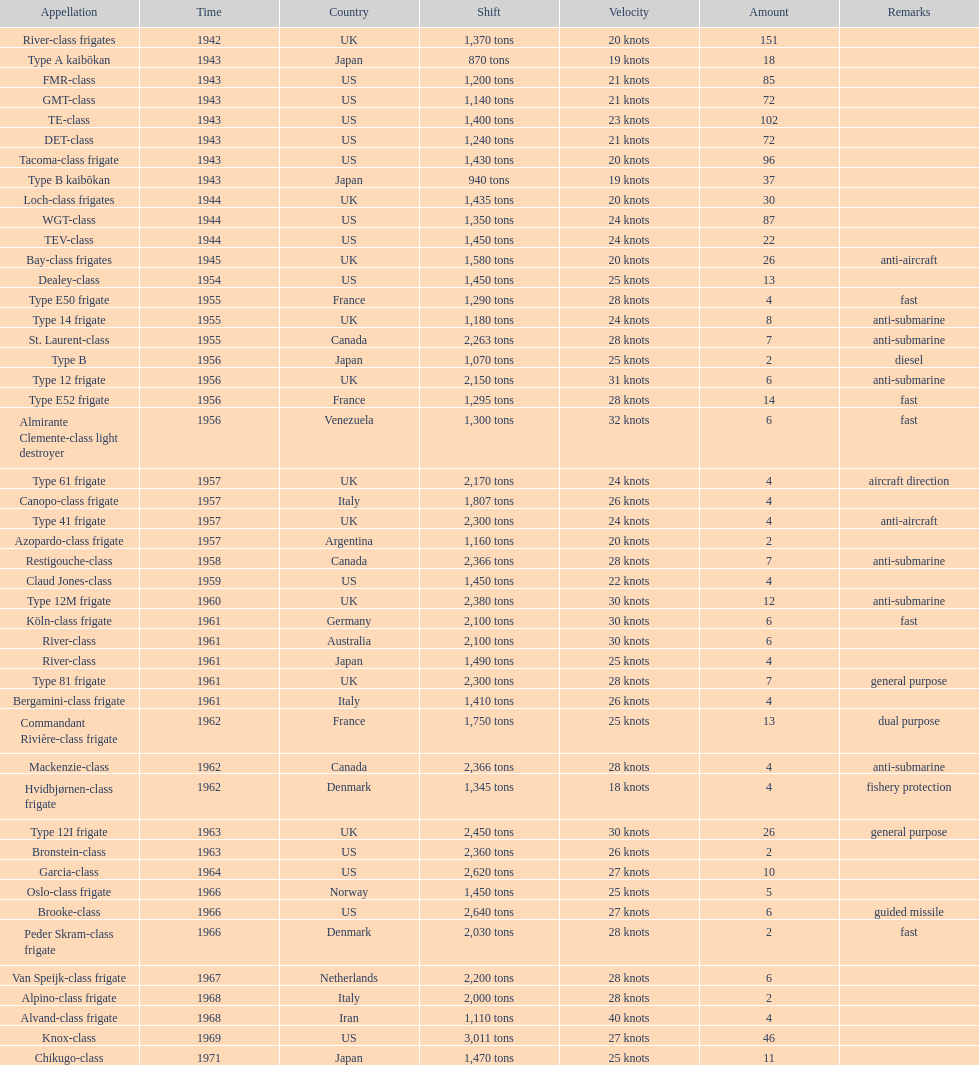How many tons does the te-class displace? 1,400 tons. 